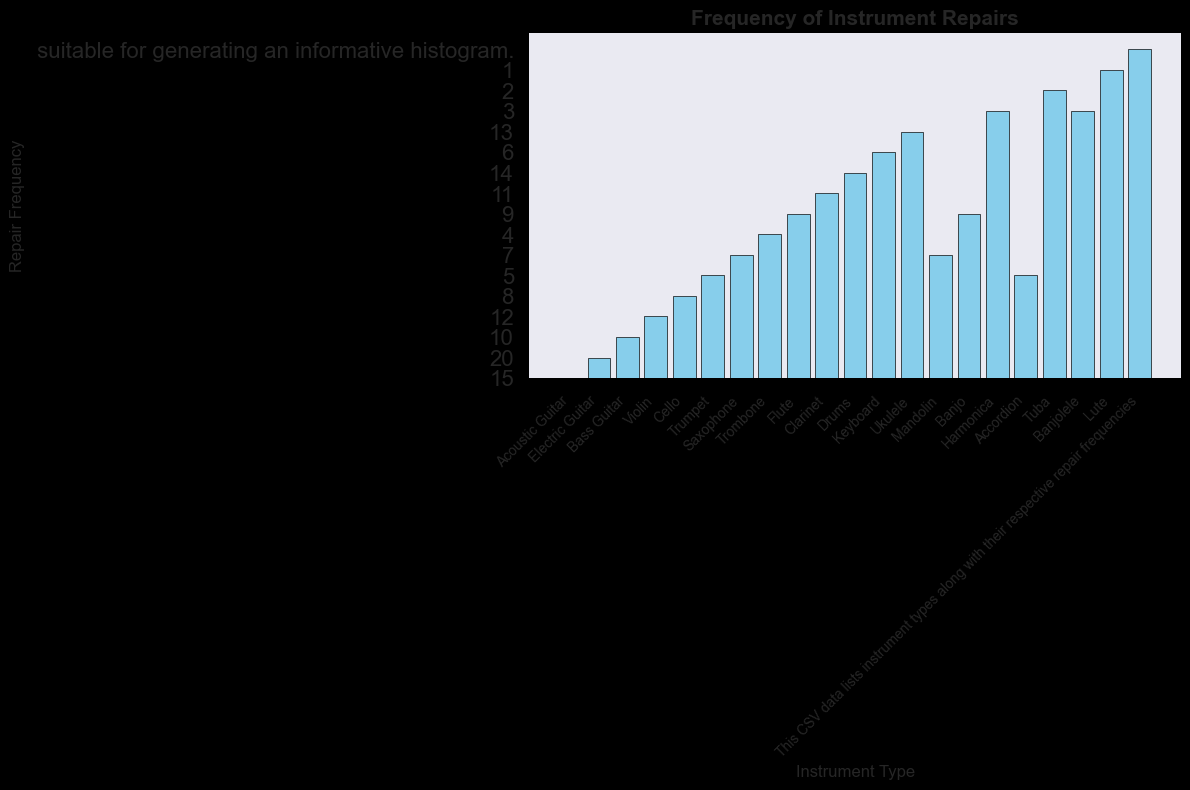Which instrument type has the highest repair frequency? Observe the heights of the bars in the histogram. The bar representing the 'Electric Guitar' is the tallest.
Answer: Electric Guitar Which instrument has the lowest frequency of repairs? Check the shortest bar in the histogram, which corresponds to 'Lute'.
Answer: Lute What is the total number of instrument repairs for all string instruments (Acoustic Guitar, Electric Guitar, Bass Guitar, Violin, Cello, Ukulele, Mandolin, Banjo, Banjolele, Lute)? Sum the frequencies of all mentioned string instruments: 15 + 20 + 10 + 12 + 8 + 13 + 7 + 9 + 3 + 1 = 98
Answer: 98 How does the repair frequency of the Trumpet compare to the Trombone? Compare the heights of the bars for 'Trumpet' and 'Trombone'. The Trumpet bar is higher (5) than the Trombone bar (4).
Answer: Trumpet has a higher repair frequency Are there more repairs for percussion instruments (Drums) or woodwind instruments (Saxophone, Flute, Clarinet)? Compare the frequency of Drums (14) with the sum of frequencies of Saxophone (7), Flute (9), and Clarinet (11): 7 + 9 + 11 = 27. The total for woodwinds (27) is higher than that for percussion (14).
Answer: Woodwind instruments What is the average repair frequency for the brass instruments (Trumpet, Trombone, Tuba)? Calculate the average by summing their frequencies and dividing by the number of instruments: (5 + 4 + 2) / 3 = 11 / 3 = 3.67
Answer: 3.67 Which has a higher repair frequency: the Accordion or the Harmonica? Look at the respective bars. The Accordion (5) has a higher frequency than the Harmonica (3).
Answer: Accordion Is the repair frequency of the Flute equal to the Mandolin? Compare the heights of the 'Flute' and 'Mandolin' bars. Both have the same height (9).
Answer: Yes What is the combined repair frequency for the Keyboard and the Drums? Add the frequencies of Keyboard (6) and Drums (14): 6 + 14 = 20
Answer: 20 Does the Ukulele have a higher or lower repair frequency compared to the Cello? Compare the heights of their bars. Ukulele (13) is higher than Cello (8).
Answer: Ukulele has a higher repair frequency 